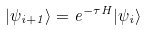<formula> <loc_0><loc_0><loc_500><loc_500>| \psi _ { i + 1 } \rangle = e ^ { - \tau H } | \psi _ { i } \rangle</formula> 